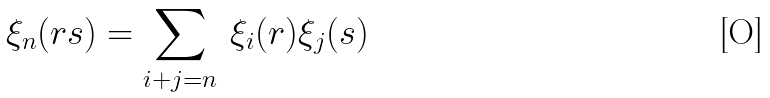<formula> <loc_0><loc_0><loc_500><loc_500>\xi _ { n } ( r s ) = \sum _ { i + j = n } \, \xi _ { i } ( r ) \xi _ { j } ( s )</formula> 